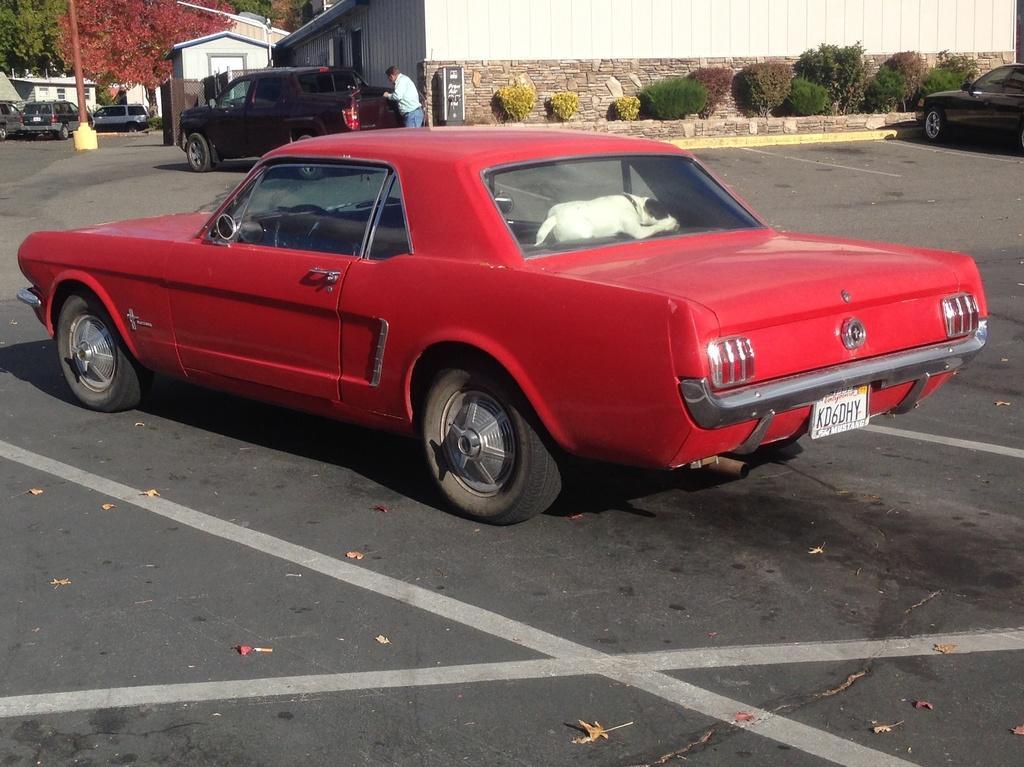How would you summarize this image in a sentence or two? The red car is highlighted in this picture. This car has number plate and wheels. In this red car there is a dog. Far there are number of plants which are in yellow, green and red color. There are many houses. These houses are in white color. Pole is in red color. Trees are in green red color. Far there are number of vehicles. Backside of this black vehicle a human is standing. 